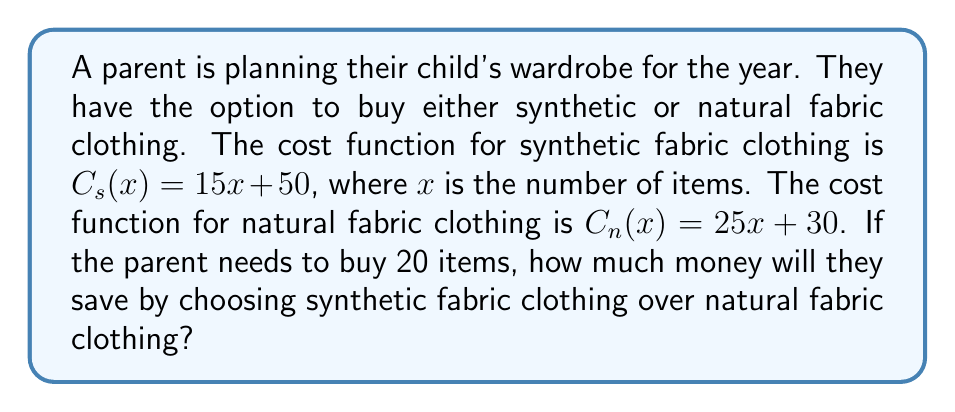What is the answer to this math problem? To solve this problem, we need to follow these steps:

1. Calculate the cost of 20 synthetic fabric items:
   $$C_s(20) = 15(20) + 50 = 300 + 50 = 350$$

2. Calculate the cost of 20 natural fabric items:
   $$C_n(20) = 25(20) + 30 = 500 + 30 = 530$$

3. Calculate the difference between the two costs:
   $$\text{Savings} = C_n(20) - C_s(20) = 530 - 350 = 180$$

Therefore, by choosing synthetic fabric clothing over natural fabric clothing for 20 items, the parent will save $180.
Answer: $180 